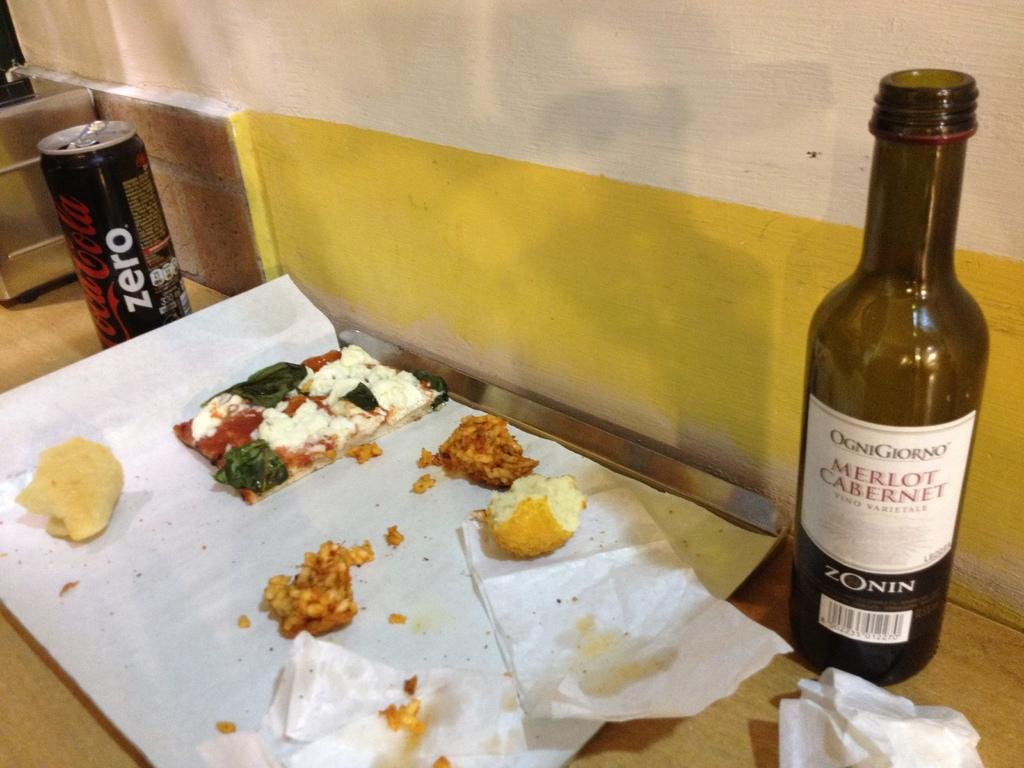What type of disposable paper product is present in the image? There are tissue papers in the image. What else can be seen in the image besides tissue papers? There are food items, a tray, a bottle, and a tin in the image. What is the object on a platform in the image? The object on a platform is not specified in the facts, but it is mentioned that there is an object on a platform. What is the background of the image? There is a wall in the background of the image. What type of crack can be seen in the image? There is no crack present in the image. Is there a coil visible in the image? There is no coil mentioned in the facts, so it cannot be determined if one is present in the image. 